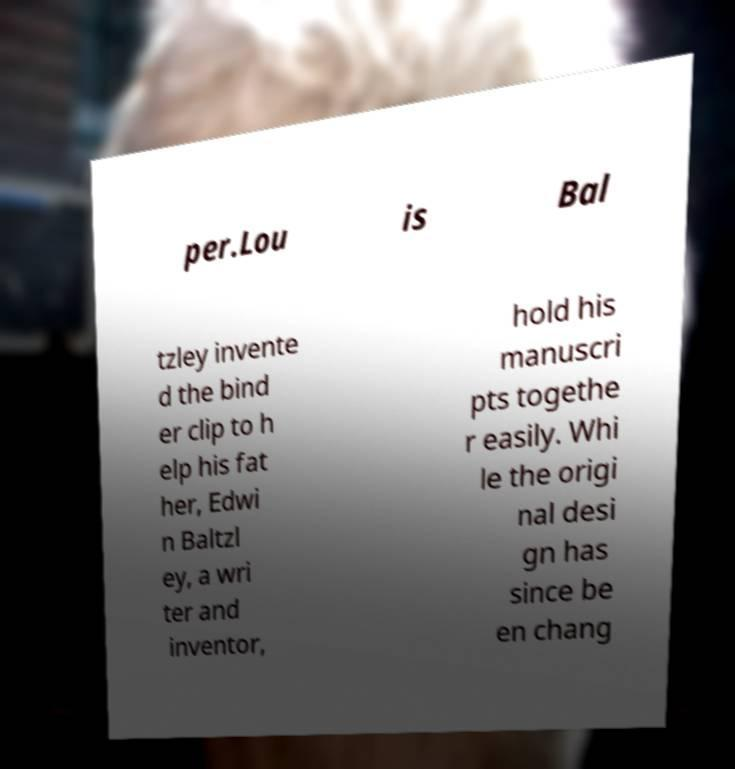I need the written content from this picture converted into text. Can you do that? per.Lou is Bal tzley invente d the bind er clip to h elp his fat her, Edwi n Baltzl ey, a wri ter and inventor, hold his manuscri pts togethe r easily. Whi le the origi nal desi gn has since be en chang 